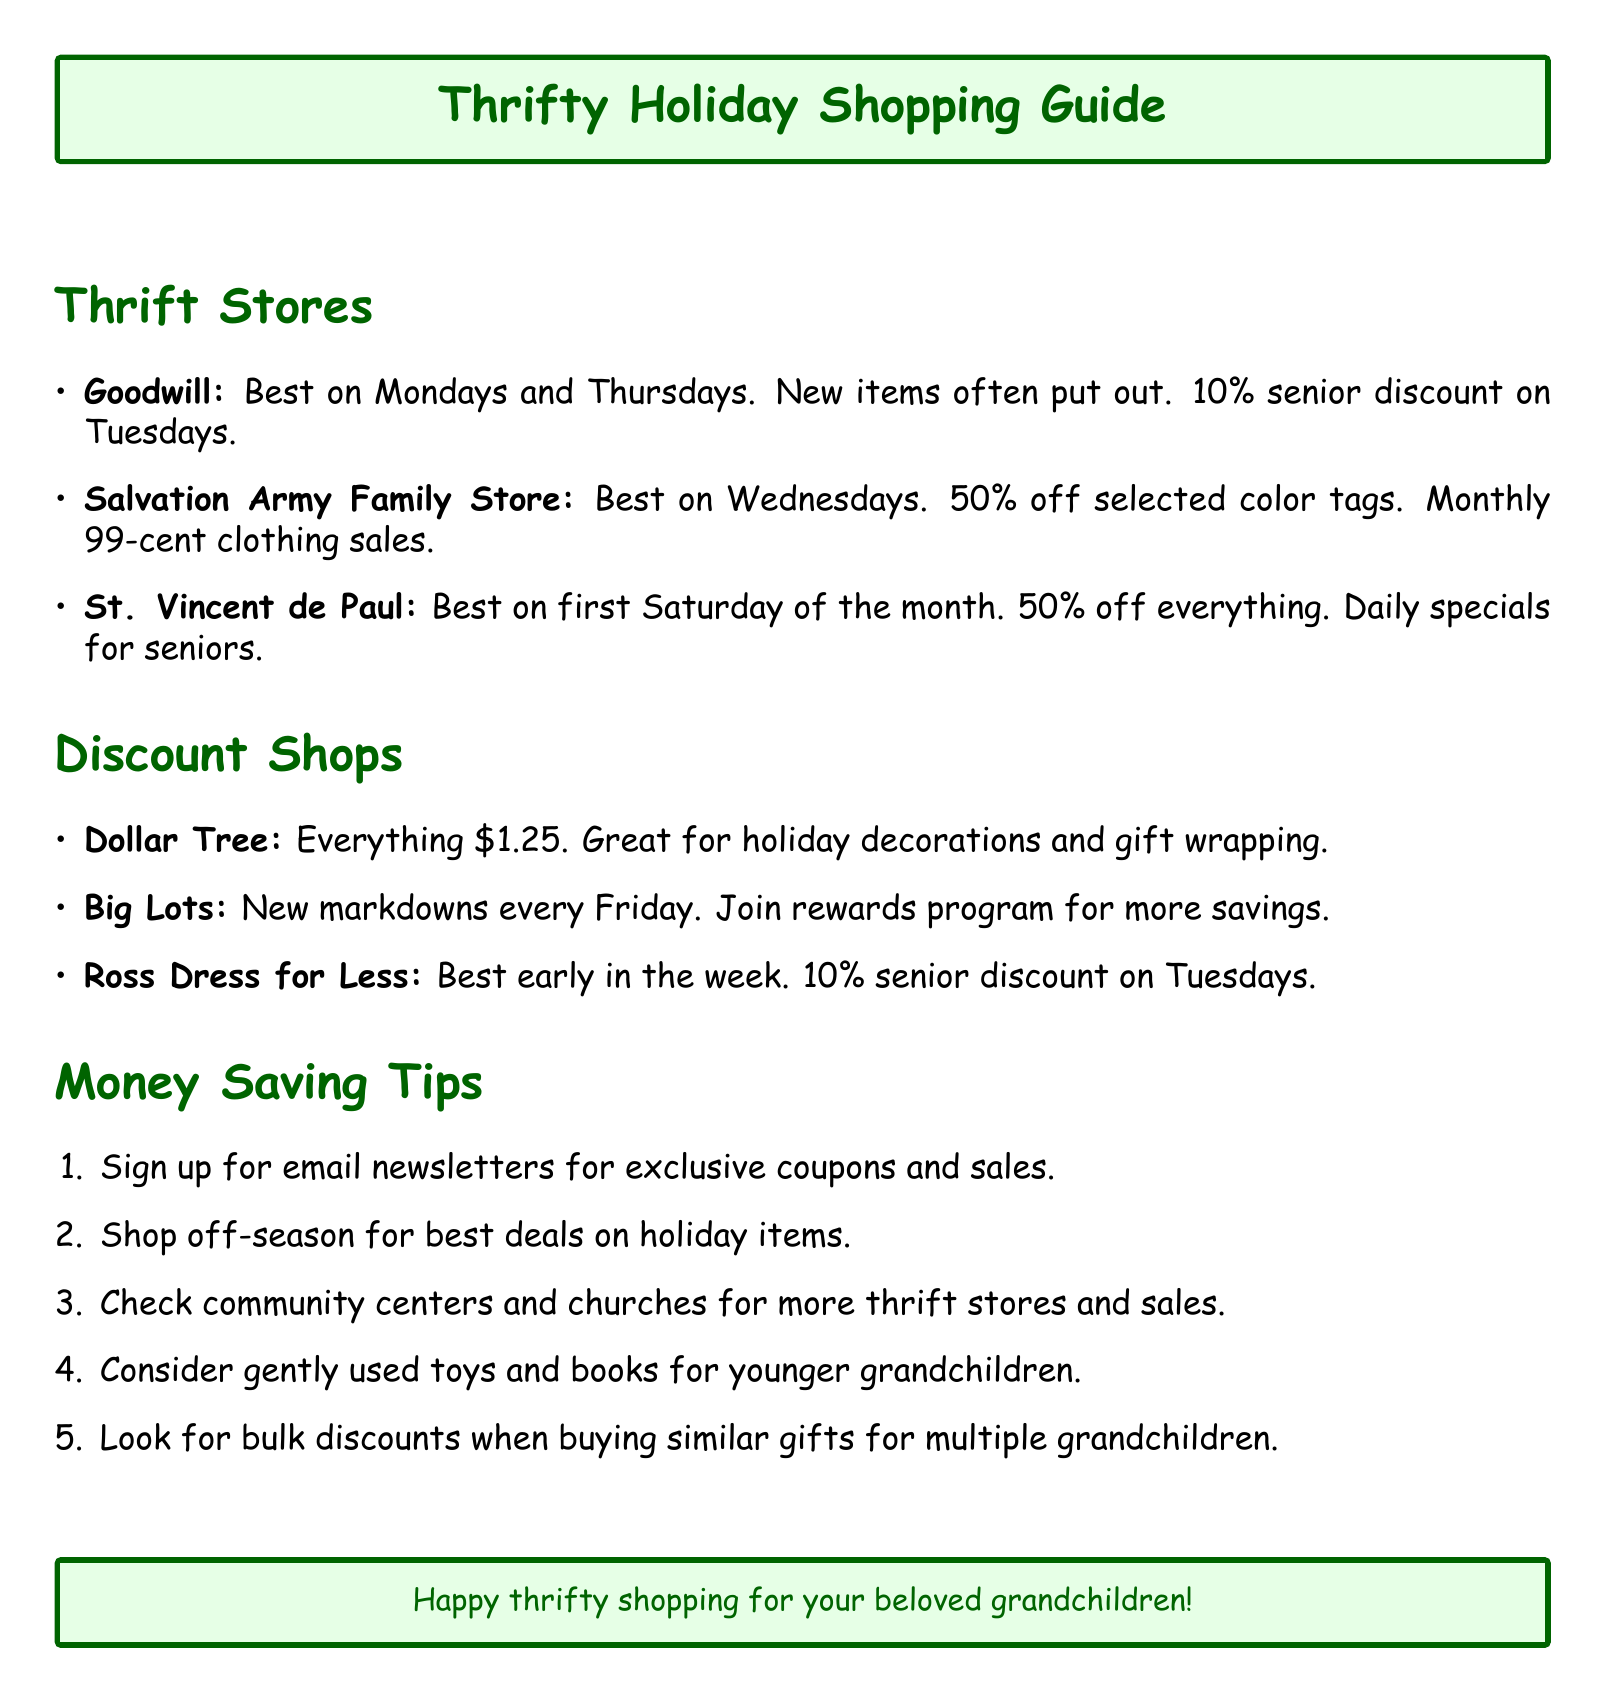What are the best days to shop at Goodwill? Goodwill's best days are mentioned in the document as Mondays and Thursdays, making it easy to remember.
Answer: Mondays and Thursdays What discount is offered for seniors at Goodwill? The document states that Goodwill offers a 10% senior discount on Tuesdays, highlighting a specific benefit for senior shoppers.
Answer: 10% What day offers half-price sales at the Salvation Army Family Store? The document notes that selected color tags are 50% off on Wednesdays, showcasing one of the store's best days for bargains.
Answer: Wednesdays When does St. Vincent de Paul have 50% off storewide? The document specifies that the first Saturday of the month features a storewide 50% discount, making it an appealing time to shop.
Answer: First Saturday of the month Which store has everything priced at $1.25? The document clearly states that Dollar Tree has everything for $1.25, which is a simple and straightforward pricing model.
Answer: Dollar Tree On what day does Big Lots introduce new markdowns? According to the document, Big Lots refreshes its markdowns every Friday, providing a regular opportunity for savings.
Answer: Fridays What type of products does Dollar Tree offer? The document mentions that Dollar Tree is great for holiday decorations and gift wrapping supplies, indicating what shoppers can find there.
Answer: Holiday decorations and gift wrapping What should you consider buying for younger grandchildren? The document suggests gently used toys and books as a budget-friendly option for gifts, which might be insightful for thrift shoppers.
Answer: Gently used toys and books How can you receive exclusive coupons? The document advises signing up for email newsletters to receive exclusive coupons and sale notifications, giving a clear method for potential savings.
Answer: Email newsletters 